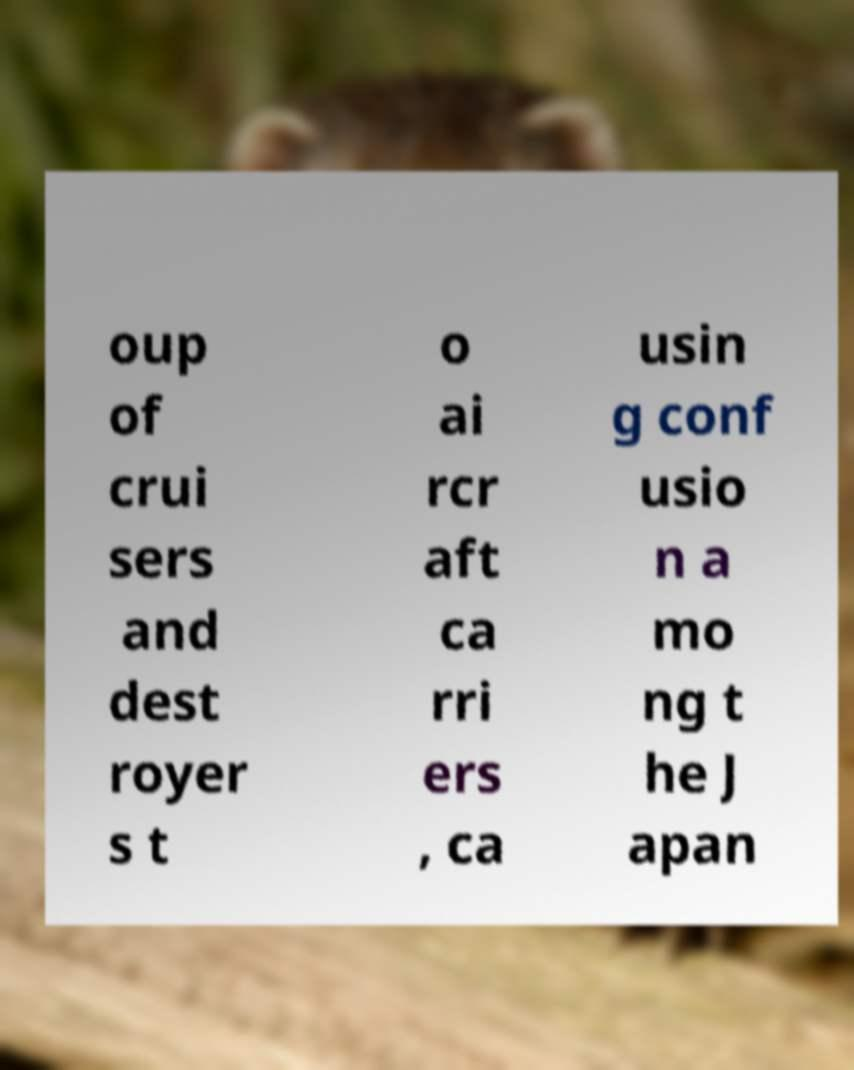Can you read and provide the text displayed in the image?This photo seems to have some interesting text. Can you extract and type it out for me? oup of crui sers and dest royer s t o ai rcr aft ca rri ers , ca usin g conf usio n a mo ng t he J apan 